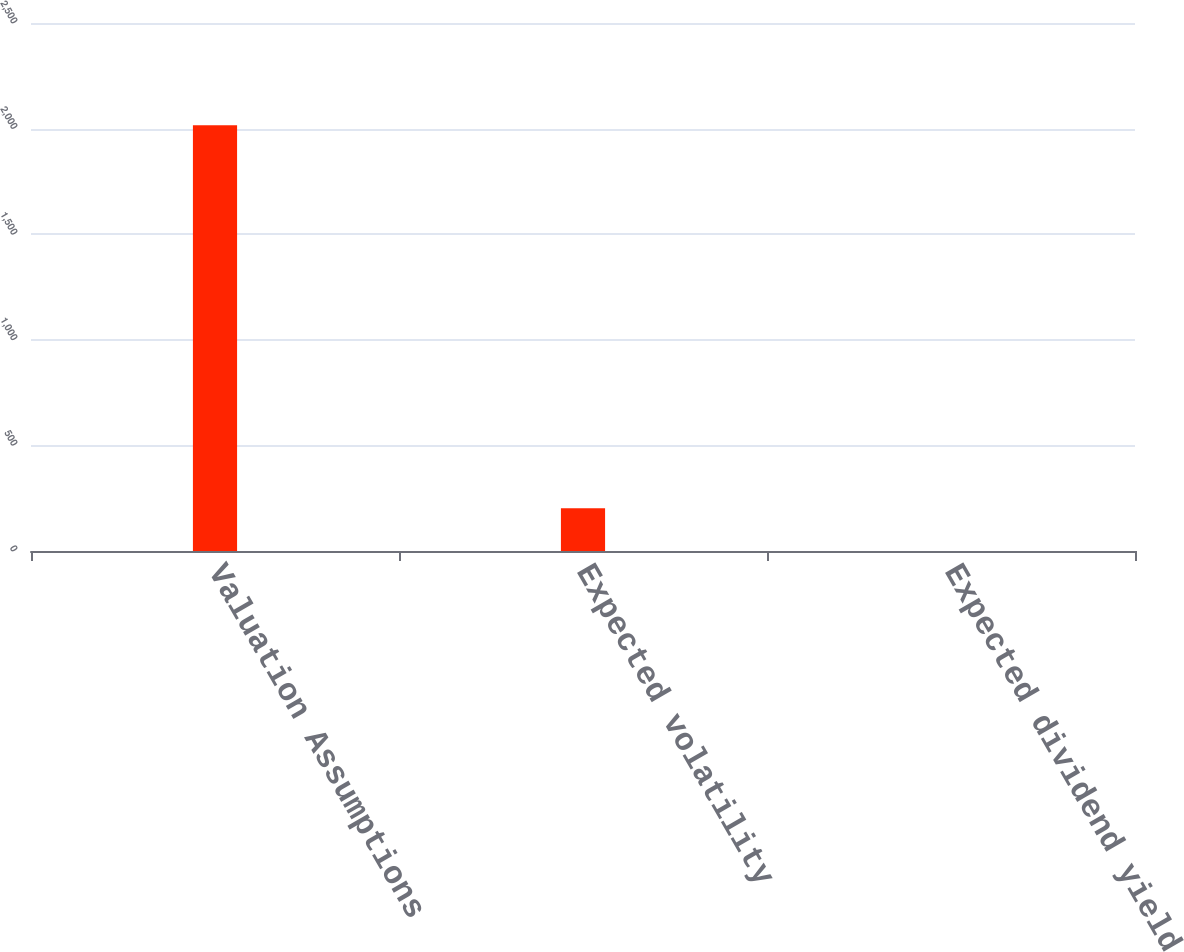Convert chart. <chart><loc_0><loc_0><loc_500><loc_500><bar_chart><fcel>Valuation Assumptions<fcel>Expected volatility<fcel>Expected dividend yield<nl><fcel>2016<fcel>201.96<fcel>0.4<nl></chart> 